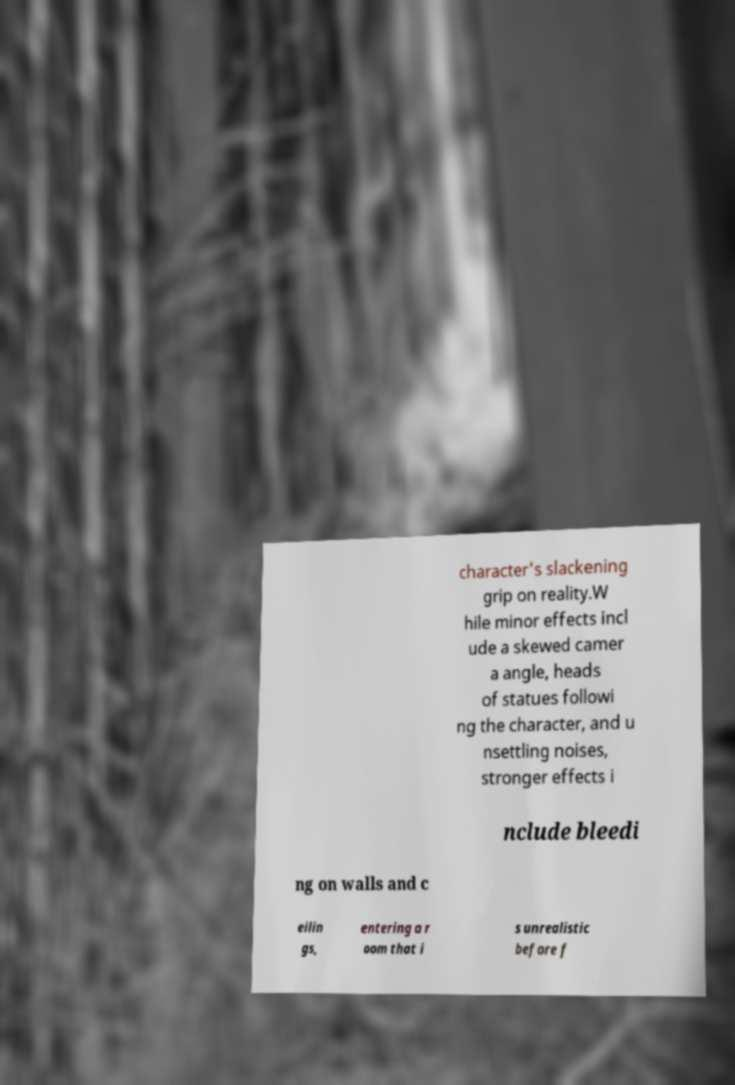Can you accurately transcribe the text from the provided image for me? character's slackening grip on reality.W hile minor effects incl ude a skewed camer a angle, heads of statues followi ng the character, and u nsettling noises, stronger effects i nclude bleedi ng on walls and c eilin gs, entering a r oom that i s unrealistic before f 